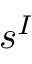<formula> <loc_0><loc_0><loc_500><loc_500>s ^ { I }</formula> 